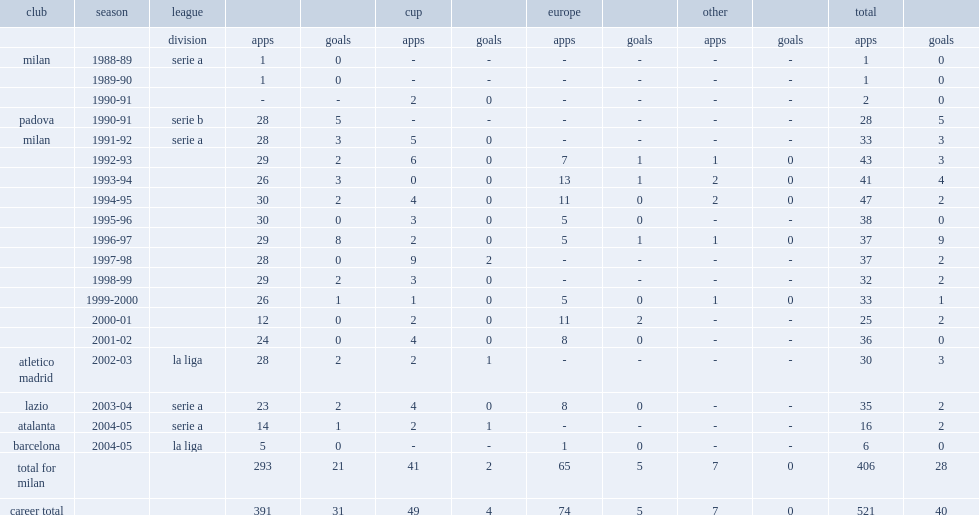How many appearances did demetrio albertini play in 1990-91 season for padova calcio in serie b score? 28.0. How many goals did demetrio albertini play in 1990-91 season for padova calcio in serie b score? 5.0. 